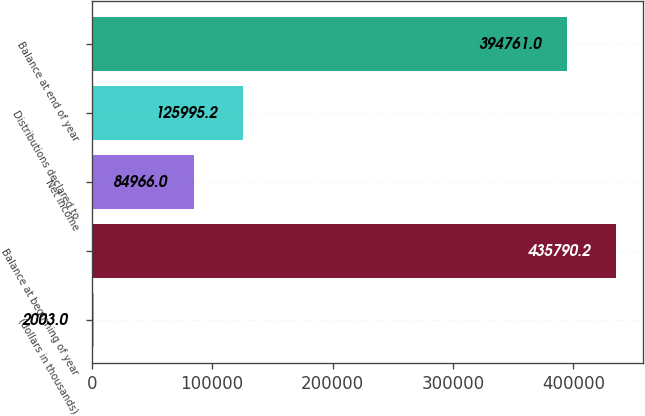Convert chart. <chart><loc_0><loc_0><loc_500><loc_500><bar_chart><fcel>(dollars in thousands)<fcel>Balance at beginning of year<fcel>Net income<fcel>Distributions declared to<fcel>Balance at end of year<nl><fcel>2003<fcel>435790<fcel>84966<fcel>125995<fcel>394761<nl></chart> 